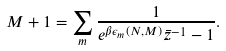<formula> <loc_0><loc_0><loc_500><loc_500>M + 1 = \sum _ { m } \frac { 1 } { e ^ { \beta \epsilon _ { m } ( N , M ) } \bar { z } ^ { - 1 } - 1 } .</formula> 